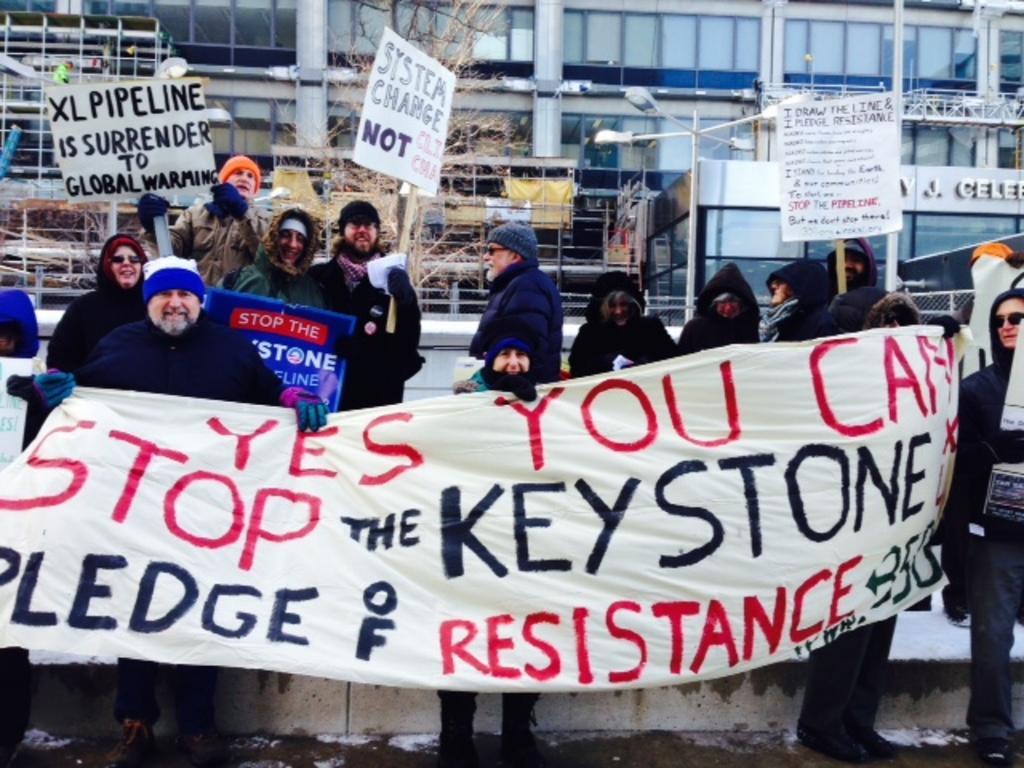Please provide a concise description of this image. In this image we can see the people holding the banner with the text. We can also see the people holding the placards and standing. In the background, we can see the trees and also the building. We can also see the light pole. 